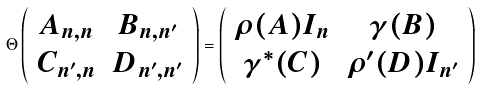<formula> <loc_0><loc_0><loc_500><loc_500>\Theta \left ( \begin{array} { c c } A _ { n , n } & B _ { n , n ^ { \prime } } \\ C _ { n ^ { \prime } , n } & D _ { n ^ { \prime } , n ^ { \prime } } \end{array} \right ) = \left ( \begin{array} { c c } \rho ( A ) I _ { n } & \gamma ( B ) \\ \gamma ^ { * } ( C ) & \rho ^ { \prime } ( D ) I _ { n ^ { \prime } } \end{array} \right )</formula> 